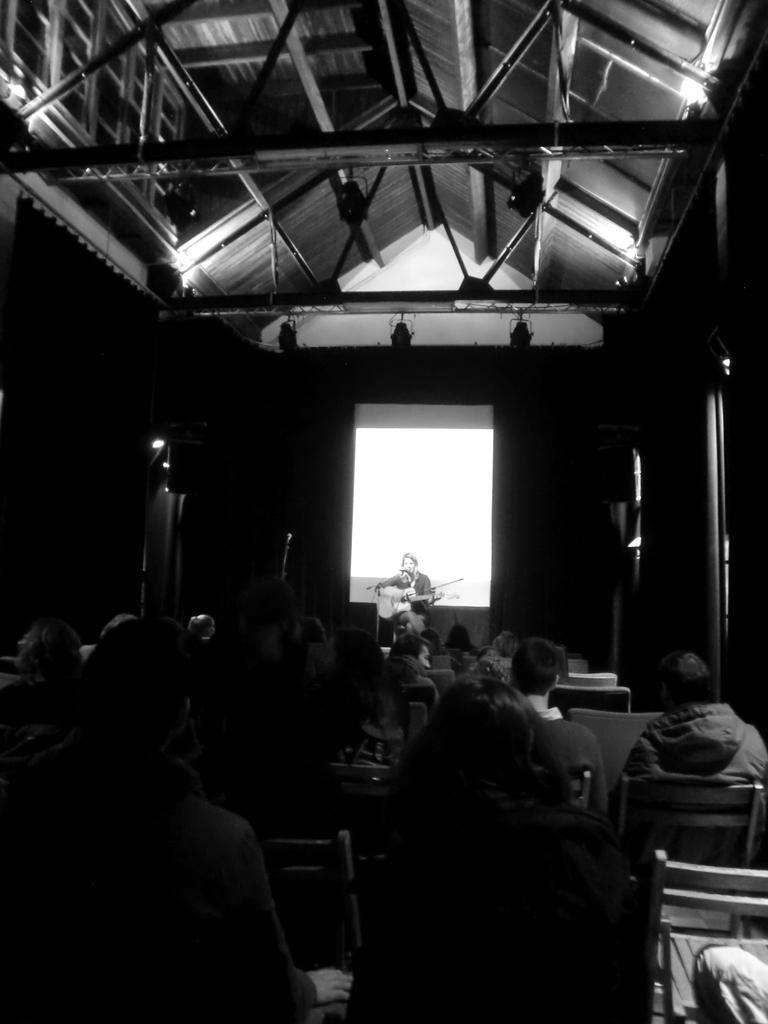Describe this image in one or two sentences. This is a black and white picture, in the back there is a person playing guitar in front of the screen and in the front there are many people sitting on chairs and staring in the front and above its sealing. 